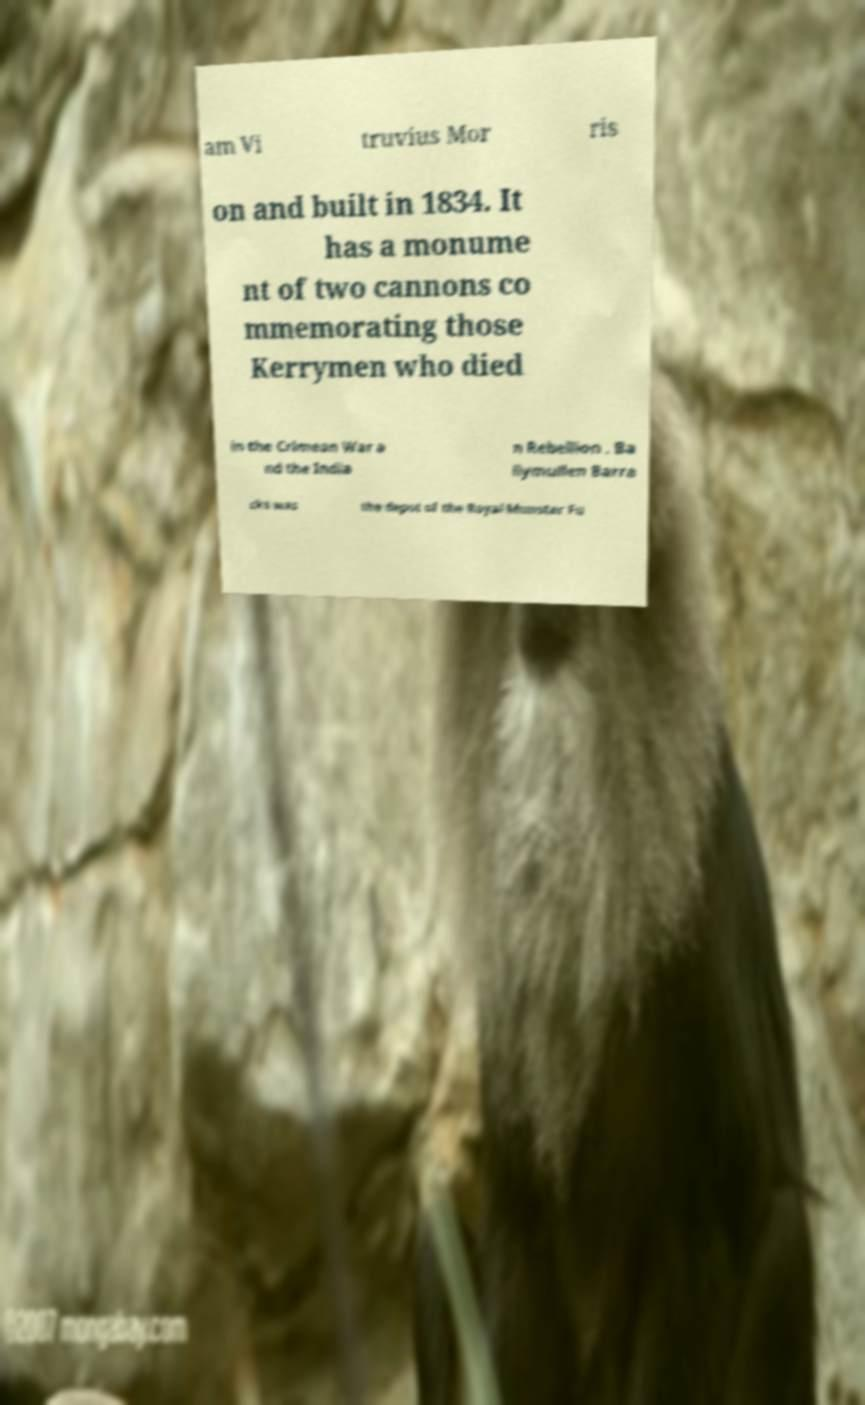Please identify and transcribe the text found in this image. am Vi truvius Mor ris on and built in 1834. It has a monume nt of two cannons co mmemorating those Kerrymen who died in the Crimean War a nd the India n Rebellion . Ba llymullen Barra cks was the depot of the Royal Munster Fu 